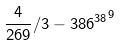<formula> <loc_0><loc_0><loc_500><loc_500>\frac { 4 } { 2 6 9 } / 3 - { 3 8 6 ^ { 3 8 } } ^ { 9 }</formula> 